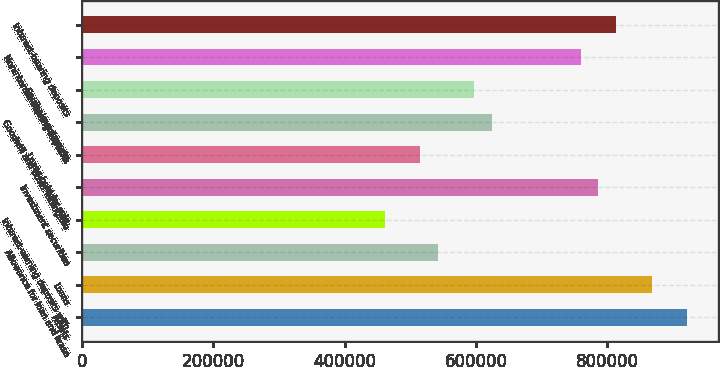<chart> <loc_0><loc_0><loc_500><loc_500><bar_chart><fcel>Assets<fcel>Loans<fcel>Allowance for loan and lease<fcel>Interest-earning deposits with<fcel>Investment securities<fcel>Loans held for sale<fcel>Goodwill and other intangible<fcel>Equity investments<fcel>Noninterest-bearing deposits<fcel>Interest-bearing deposits<nl><fcel>922094<fcel>867853<fcel>542409<fcel>461048<fcel>786492<fcel>515288<fcel>623770<fcel>596650<fcel>759372<fcel>813613<nl></chart> 